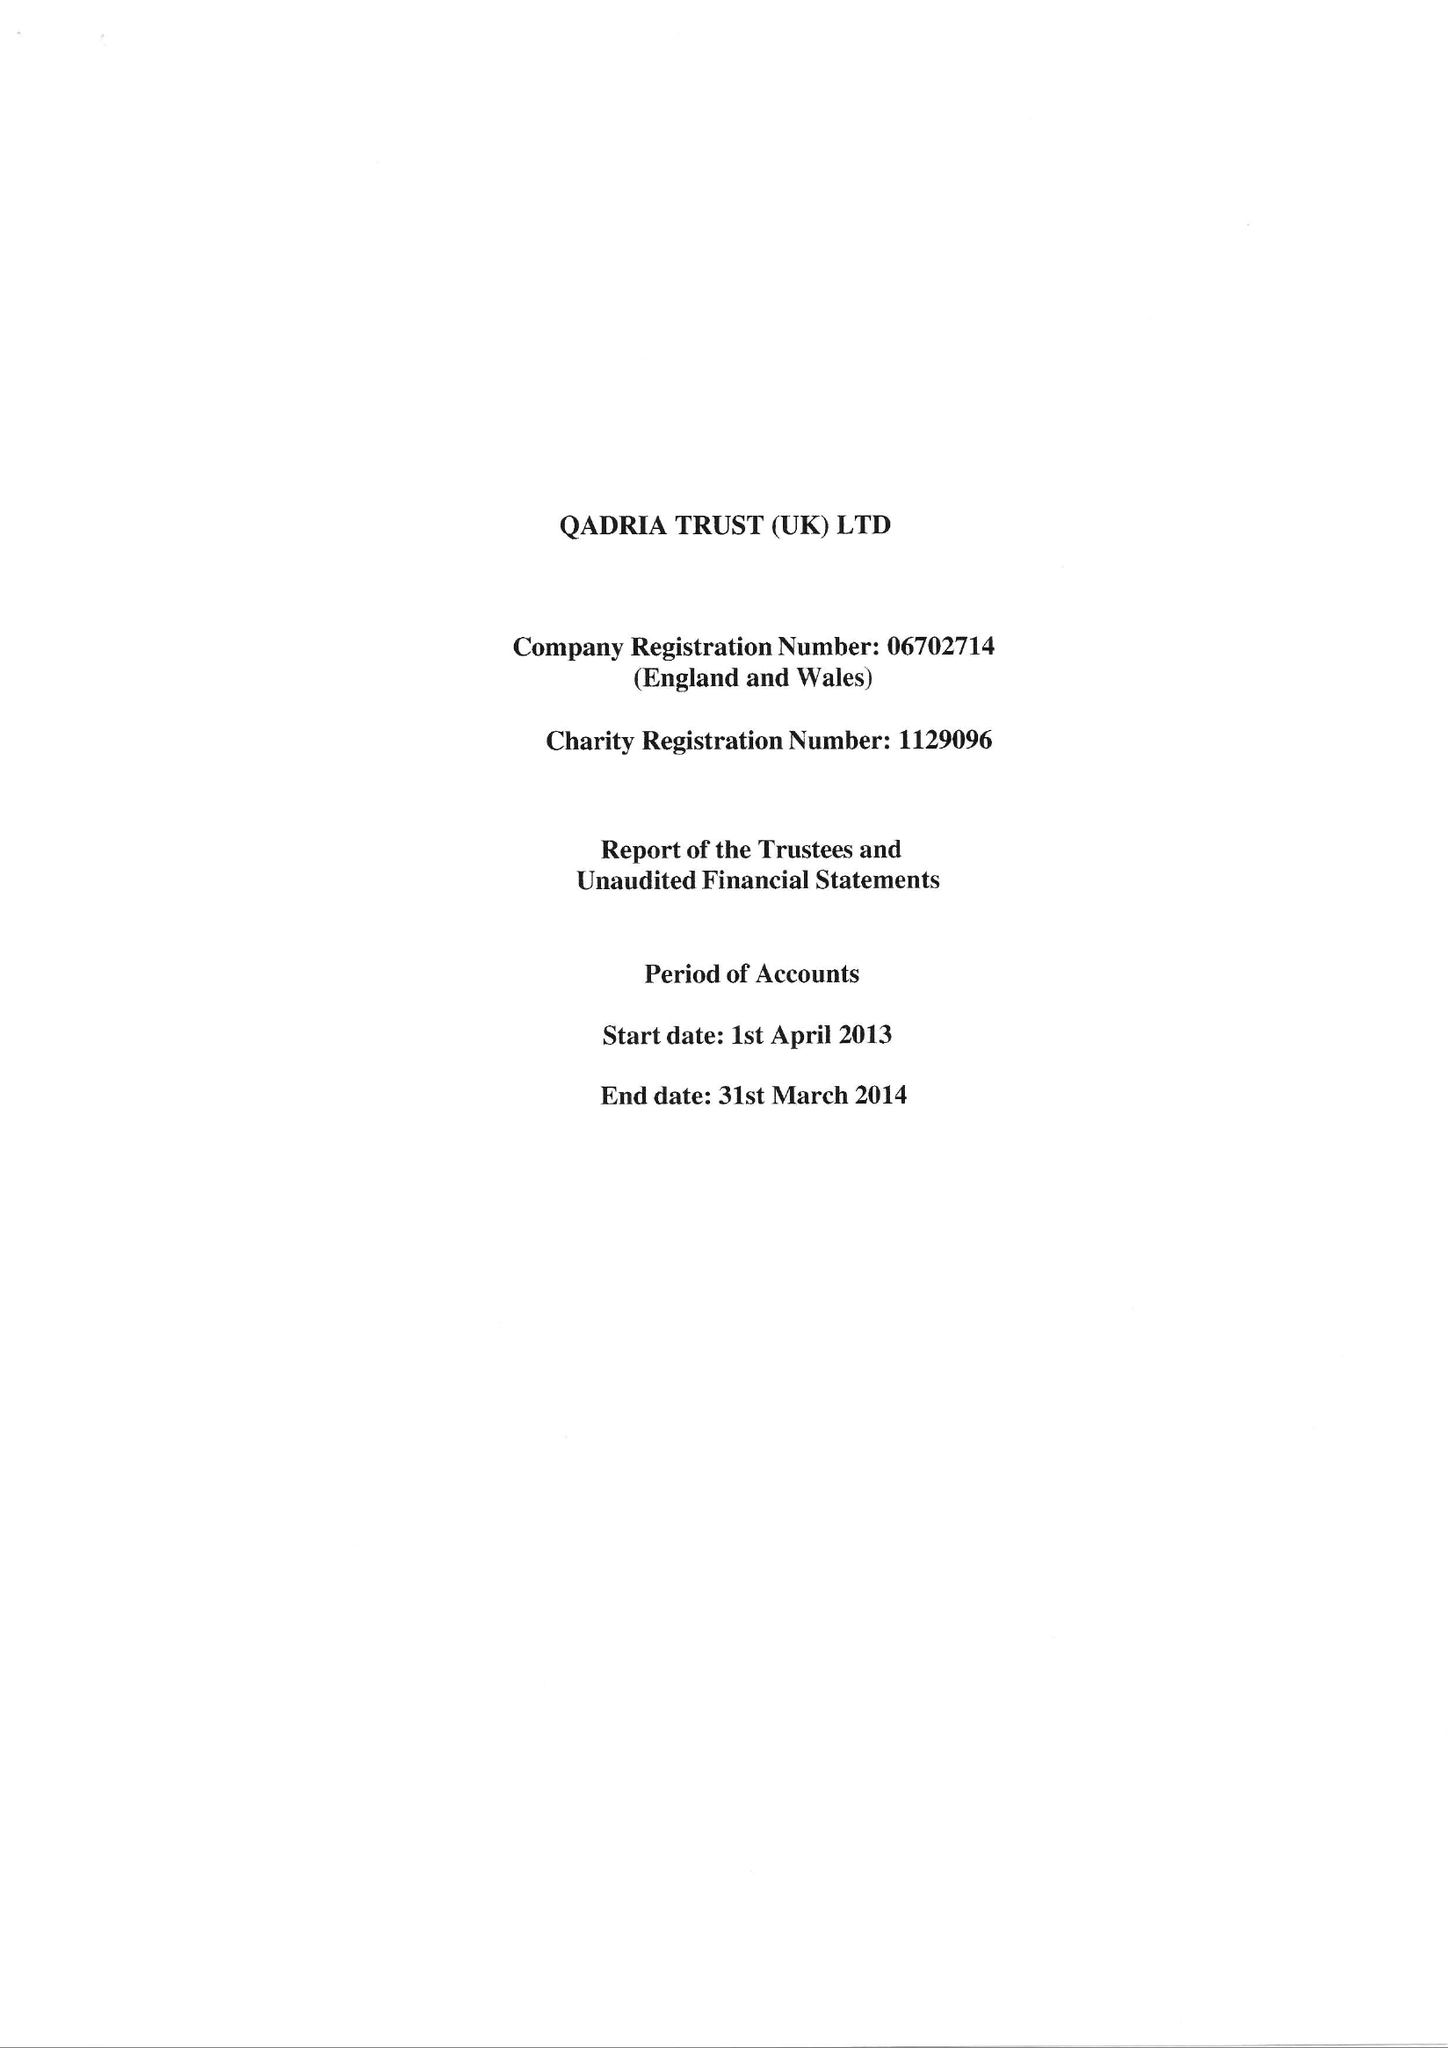What is the value for the address__postcode?
Answer the question using a single word or phrase. B12 8JL 